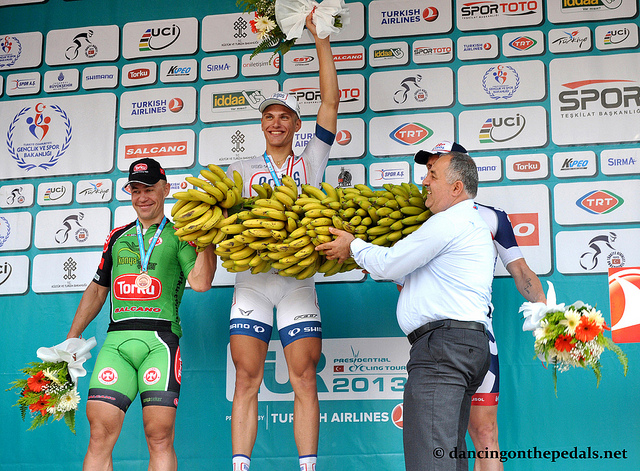Extract all visible text content from this image. 2013 AIRLINES SALCANO TRT UCi MABO TRT SIRMA KOPEO Torku DASKAND TISKILAT SPOR SPORTOTO TRT SPORTOTO AIRLINES TURKISH AND SHIb OSCAR MALCANO Torku uci iddaa Surha uci AIRLINES TURKISH Kupeo Torku TOUR Cycling PRESIDENTIAL C dancingonthepedals.net 